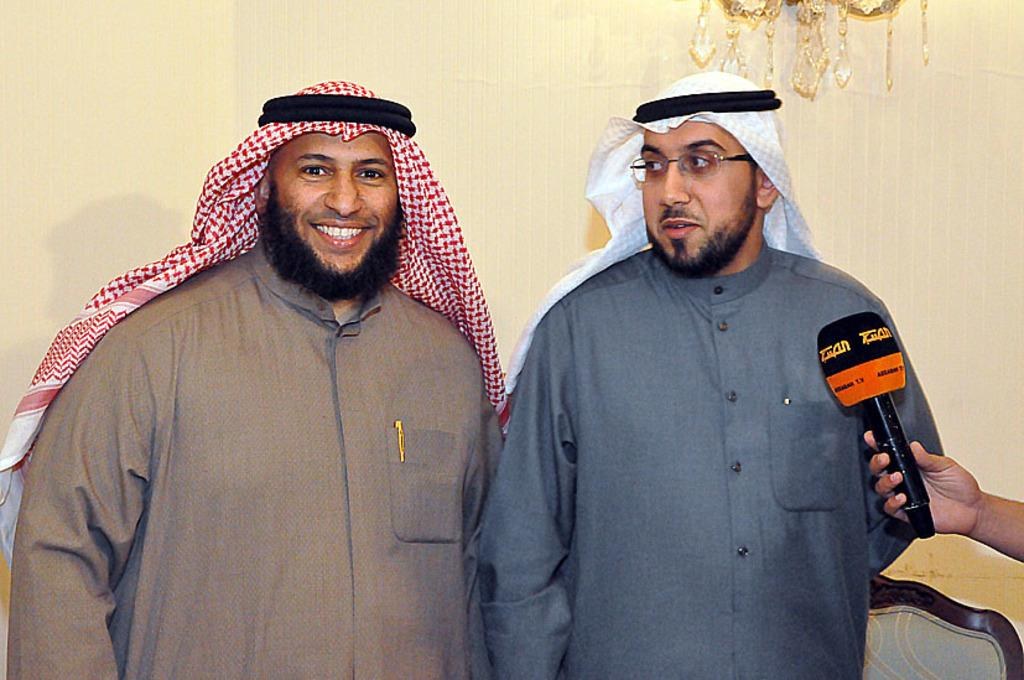How many people are present in the image? There are two men standing in the image. What is the person on the right side of the image holding? The person is holding a microphone on the right side of the image. What can be seen behind the men in the image? There is a wall at the back of the image. What type of lighting fixture is visible at the top of the image? There is a chandelier visible at the top of the image. What is the person's desire for the pipe in the image? There is no pipe present in the image, so it is not possible to determine any desires related to it. 